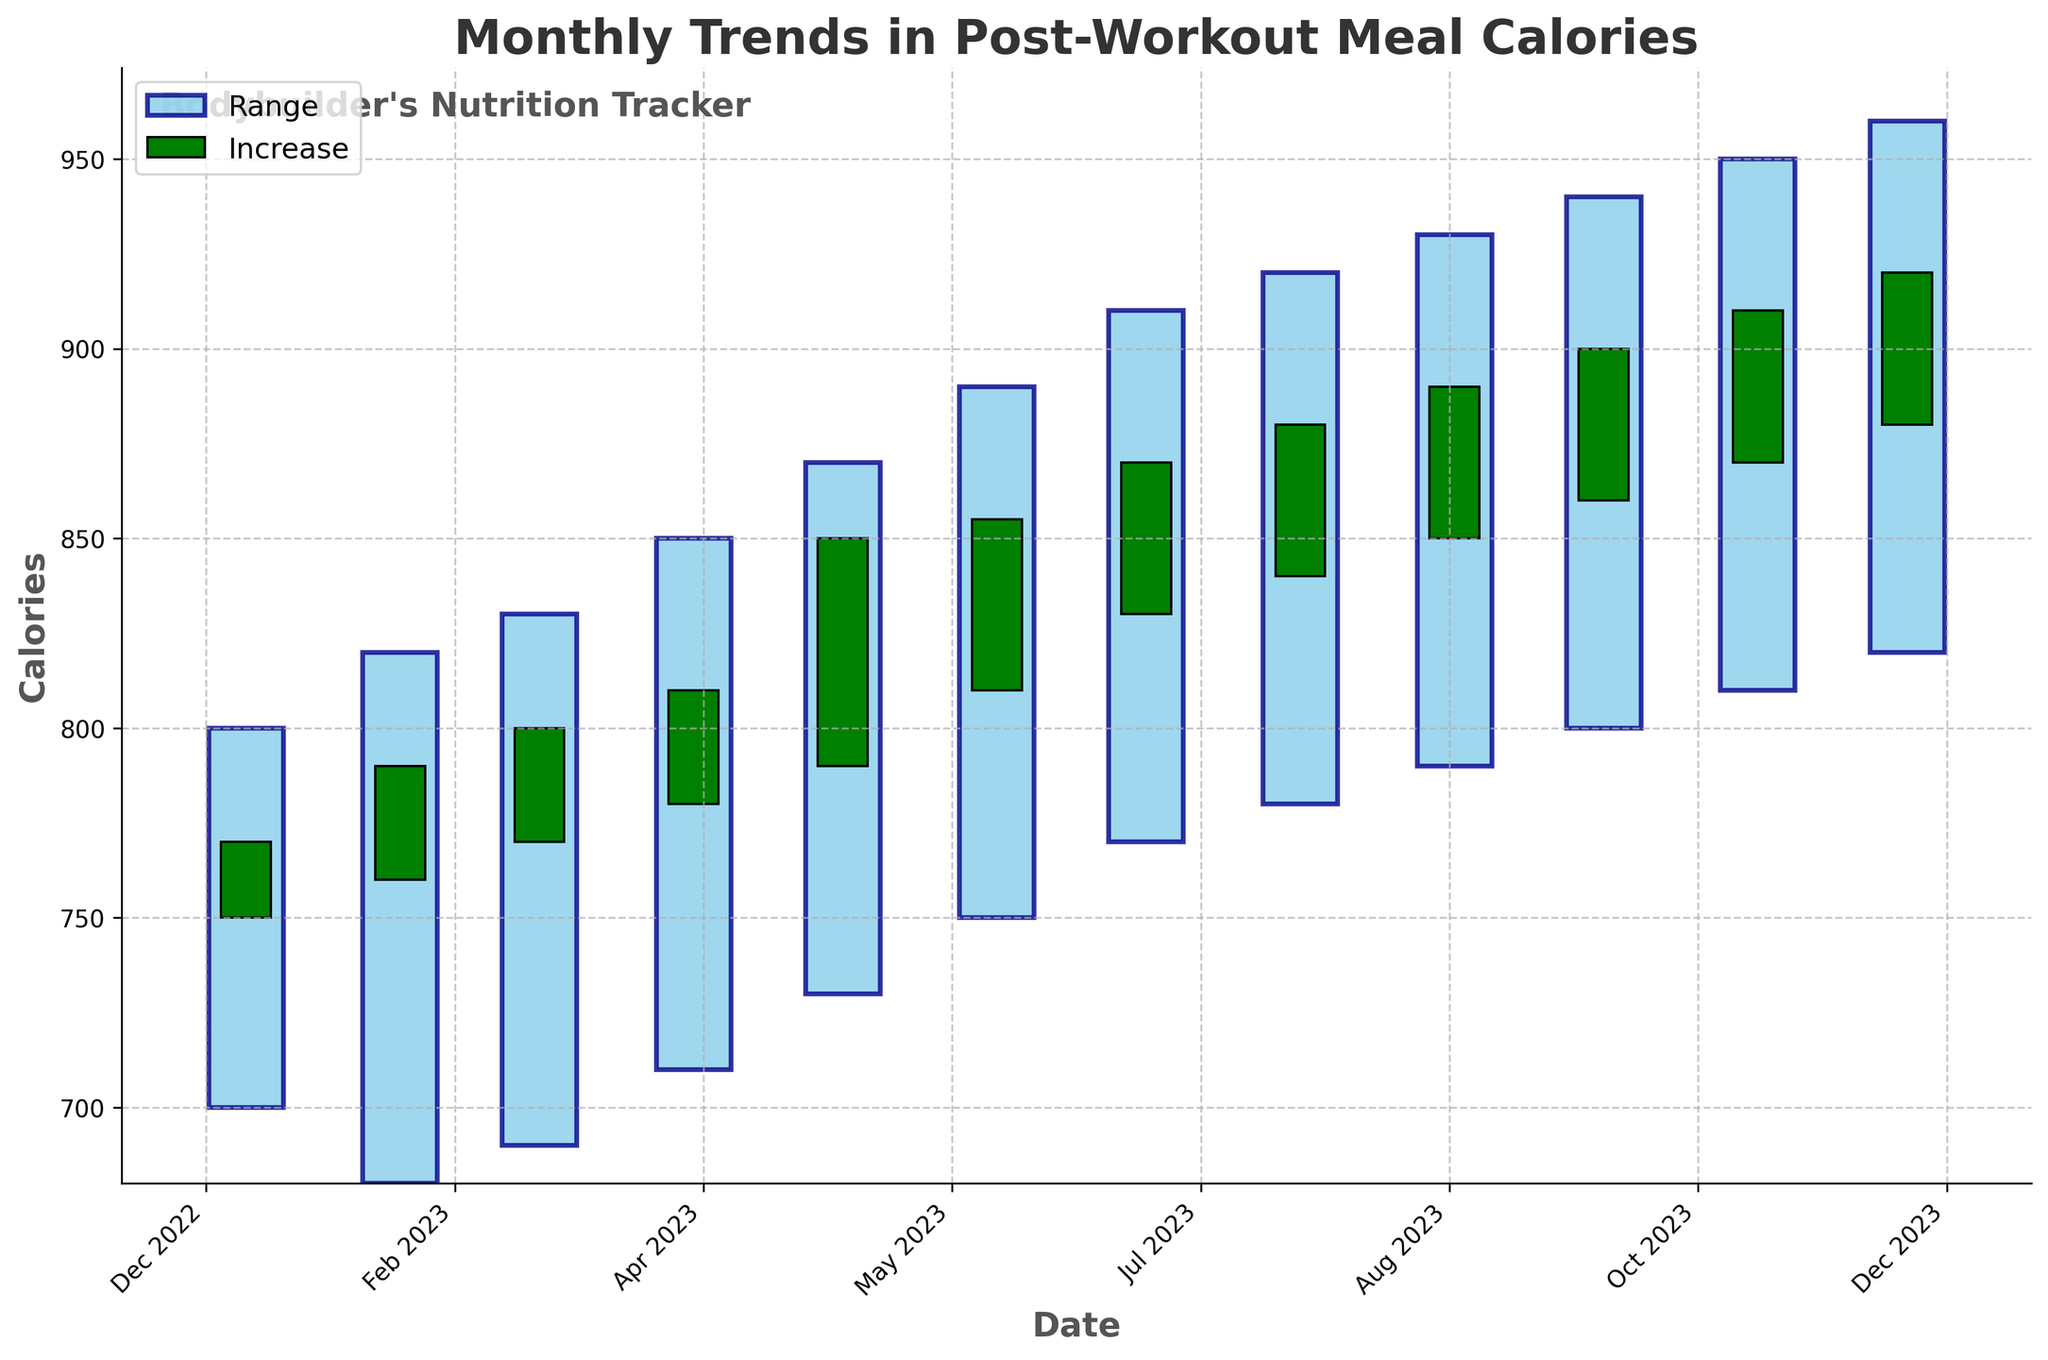What's the title of the plot? The title is usually displayed at the top of the plot and provides an overview of what the plot represents. Here, the title indicates what the data is about.
Answer: Monthly Trends in Post-Workout Meal Calories What does the x-axis represent? The labels on the x-axis typically tell you what variable is being measured along that axis. In this case, the x-axis labels represent months and years.
Answer: Date What does the y-axis represent? The labels on the y-axis typically tell you what variable is being measured along that axis. Here, it indicates the number of calories in post-workout meals.
Answer: Calories In which month was the range of calories the smallest? The range of calories is represented by the vertical bars. To find this, compare the heights of these vertical bars for each month.
Answer: January Did the calories for post-workout meals increase or decrease from January to February? To determine this, look at the colors of the candlesticks. Green means an increase (close >= open) and red means a decrease (close < open).
Answer: Increase Which month has the highest closing calories for post-workout meals? The closing calories are represented by the top end of the smaller bars within the larger range bars. The highest closing value will be the tallest of these smaller top ends.
Answer: December What is the difference in calories between the highest and lowest values in July? Find the highest and lowest values for July by looking at the top and bottom of the vertical bar for that month. Subtract the low from the high value. The high is 910 and the low is 770. 910 - 770 = 140.
Answer: 140 Which months show a decrease in calories from open to close? Months with a decrease will have red colored candles. Count the number of red candles to determine.
Answer: None What is the average "Close" value for the last three months? Find the closing calories for the last three months, which are October (900), November (910), and December (920). Add these values and divide by 3. (900 + 910 + 920) / 3 = 910.
Answer: 910 In which month did the opening calories first reach 850? Look for the first month in the data where the opening calories, represented by the bottom of the smaller bars within the larger range bars, reached at least 850.
Answer: September 